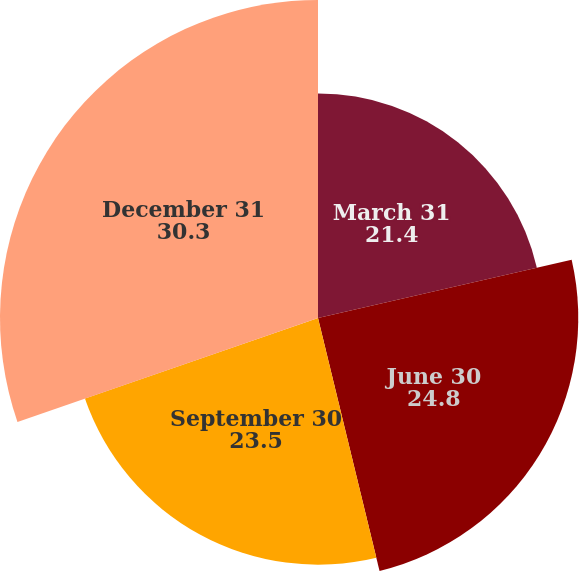Convert chart to OTSL. <chart><loc_0><loc_0><loc_500><loc_500><pie_chart><fcel>March 31<fcel>June 30<fcel>September 30<fcel>December 31<nl><fcel>21.4%<fcel>24.8%<fcel>23.5%<fcel>30.3%<nl></chart> 